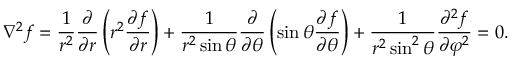Convert formula to latex. <formula><loc_0><loc_0><loc_500><loc_500>\nabla ^ { 2 } f = { \frac { 1 } { r ^ { 2 } } } { \frac { \partial } { \partial r } } \left ( r ^ { 2 } { \frac { \partial f } { \partial r } } \right ) + { \frac { 1 } { r ^ { 2 } \sin \theta } } { \frac { \partial } { \partial \theta } } \left ( \sin \theta { \frac { \partial f } { \partial \theta } } \right ) + { \frac { 1 } { r ^ { 2 } \sin ^ { 2 } \theta } } { \frac { \partial ^ { 2 } f } { \partial \varphi ^ { 2 } } } = 0 .</formula> 